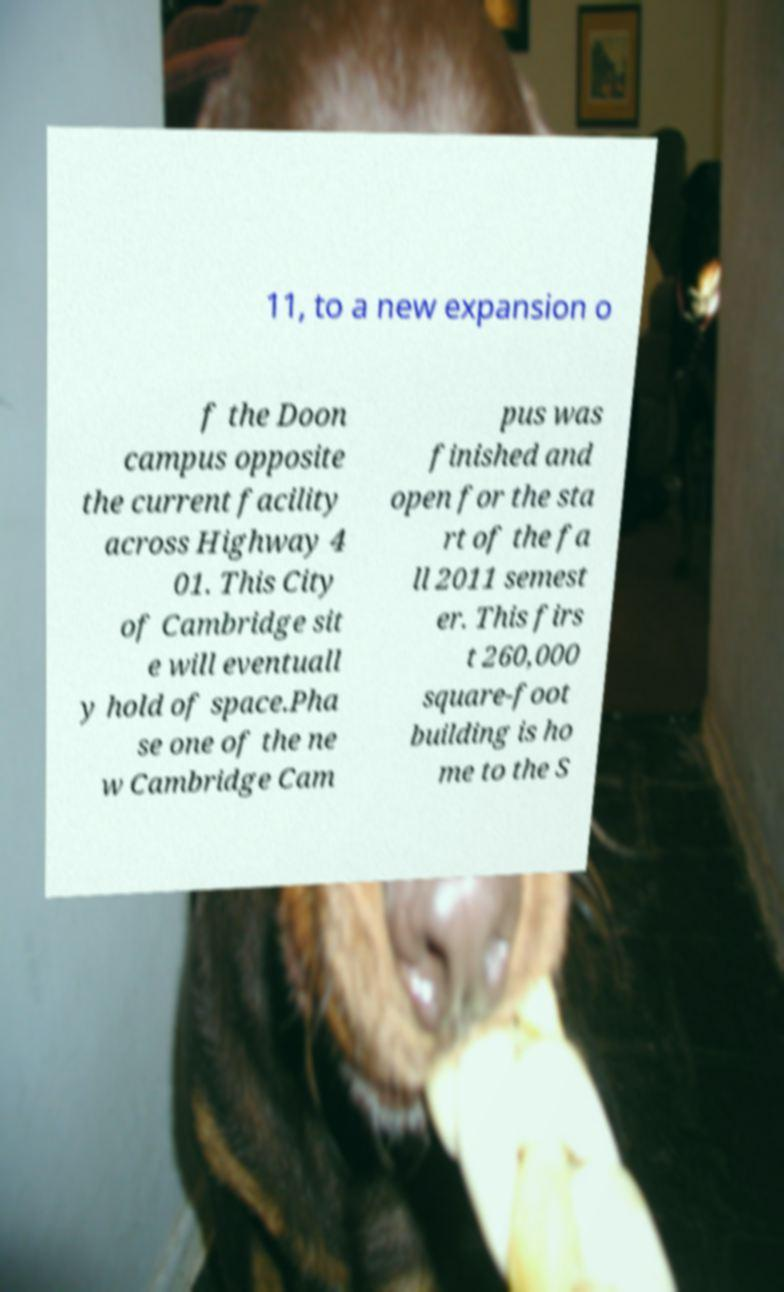What messages or text are displayed in this image? I need them in a readable, typed format. 11, to a new expansion o f the Doon campus opposite the current facility across Highway 4 01. This City of Cambridge sit e will eventuall y hold of space.Pha se one of the ne w Cambridge Cam pus was finished and open for the sta rt of the fa ll 2011 semest er. This firs t 260,000 square-foot building is ho me to the S 